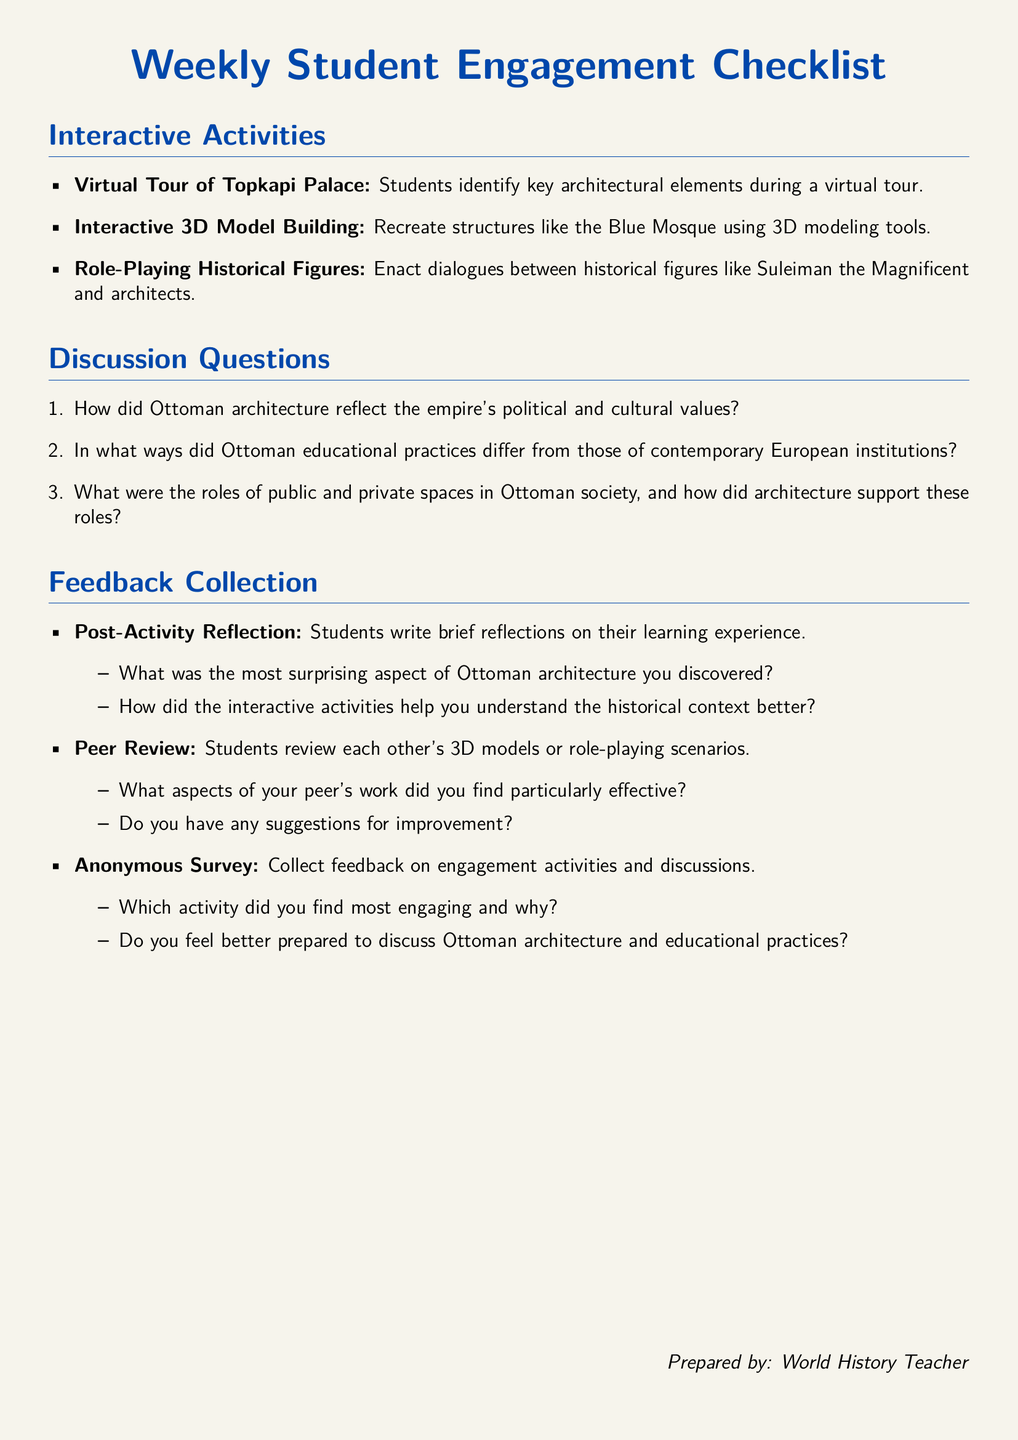What is the title of the checklist? The title is presented prominently at the top of the document.
Answer: Weekly Student Engagement Checklist How many interactive activities are listed? The number of items under the Interactive Activities section indicates how many activities are included.
Answer: 3 What is one of the discussion questions related to space in Ottoman society? The document includes various discussion questions, one of which focuses on public and private spaces.
Answer: What were the roles of public and private spaces in Ottoman society, and how did architecture support these roles? What type of feedback collection involves post-activity reflections? The document specifies a feedback collection method that encourages students to reflect on their experiences after activities.
Answer: Post-Activity Reflection Who is the document prepared by? The last section of the document names the individual responsible for its preparation.
Answer: World History Teacher What is a suggested role in the interactive activity concerning historical figures? The document describes an interactive activity that involves enacting dialogues between notable historical characters.
Answer: Role-Playing Historical Figures 